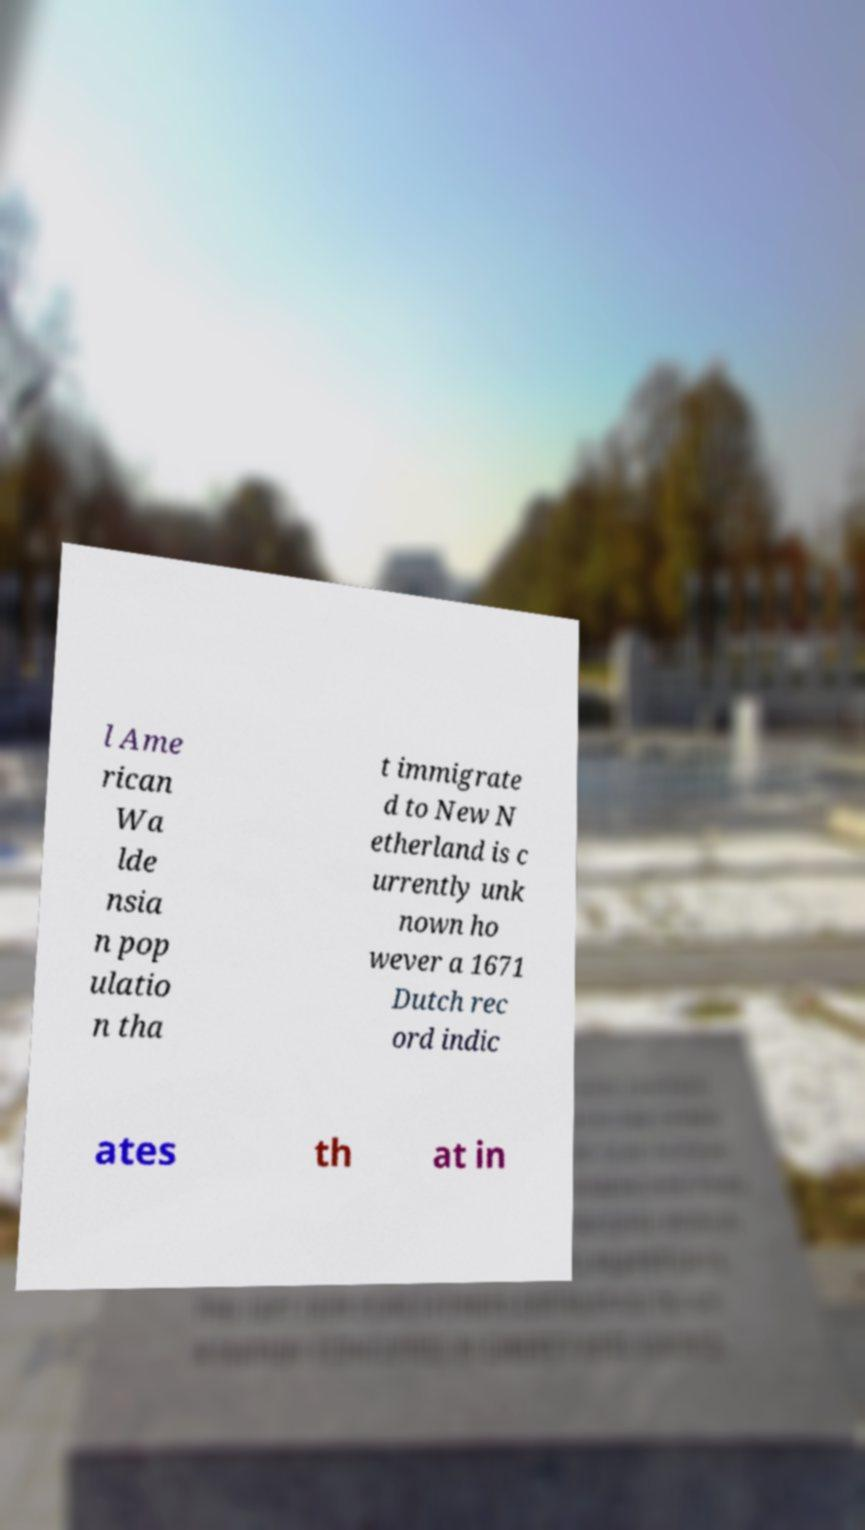Can you read and provide the text displayed in the image?This photo seems to have some interesting text. Can you extract and type it out for me? l Ame rican Wa lde nsia n pop ulatio n tha t immigrate d to New N etherland is c urrently unk nown ho wever a 1671 Dutch rec ord indic ates th at in 